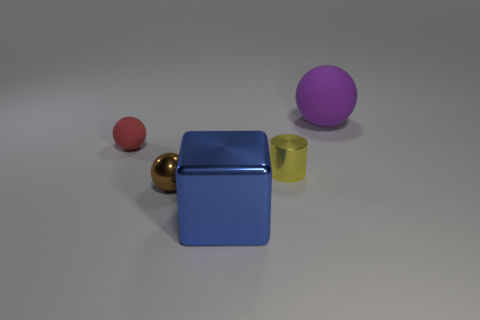Subtract all large rubber balls. How many balls are left? 2 Subtract all red spheres. How many spheres are left? 2 Subtract 1 cylinders. How many cylinders are left? 0 Add 2 tiny gray shiny objects. How many objects exist? 7 Subtract all spheres. How many objects are left? 2 Subtract all cyan cylinders. Subtract all brown cubes. How many cylinders are left? 1 Subtract all purple spheres. How many red cubes are left? 0 Subtract all small gray shiny cylinders. Subtract all small brown metallic spheres. How many objects are left? 4 Add 5 small yellow metallic cylinders. How many small yellow metallic cylinders are left? 6 Add 1 blue metal blocks. How many blue metal blocks exist? 2 